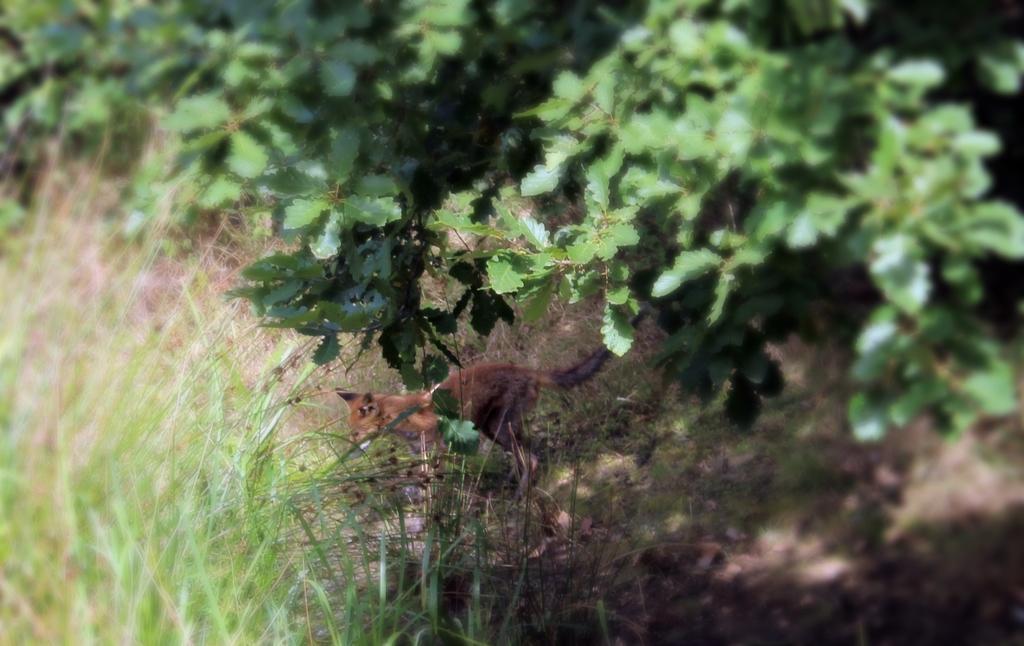Describe this image in one or two sentences. There is an animal on the grass and we can see green leaves. 